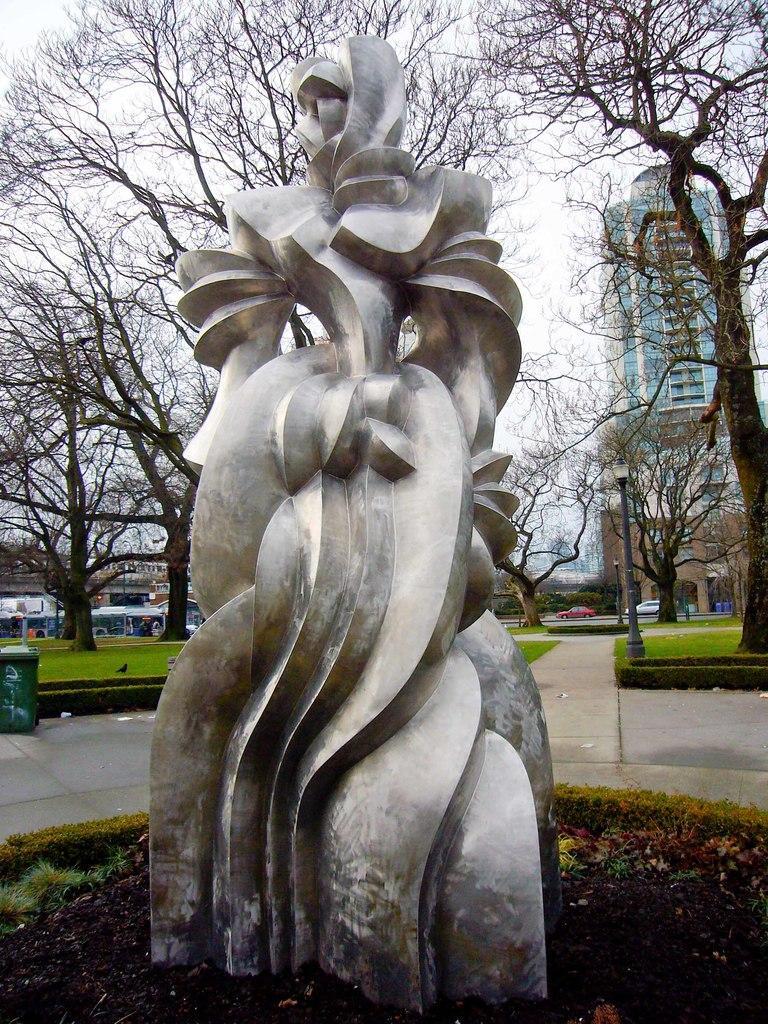Please provide a concise description of this image. In this picture we can see a statue in the front, in the background there are buildings, trees, vehicles and poles, on the left side there is a dustbin, we can see grass at the bottom, there is the sky at the top of the picture. 